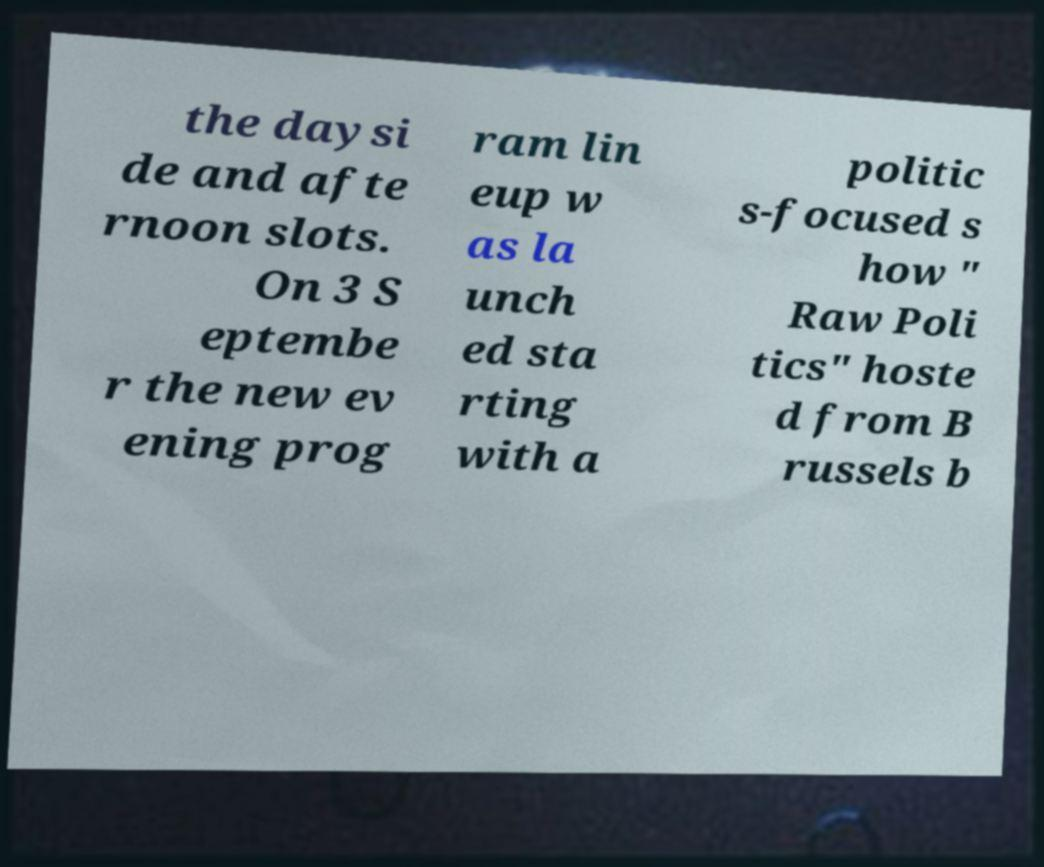Please identify and transcribe the text found in this image. the daysi de and afte rnoon slots. On 3 S eptembe r the new ev ening prog ram lin eup w as la unch ed sta rting with a politic s-focused s how " Raw Poli tics" hoste d from B russels b 